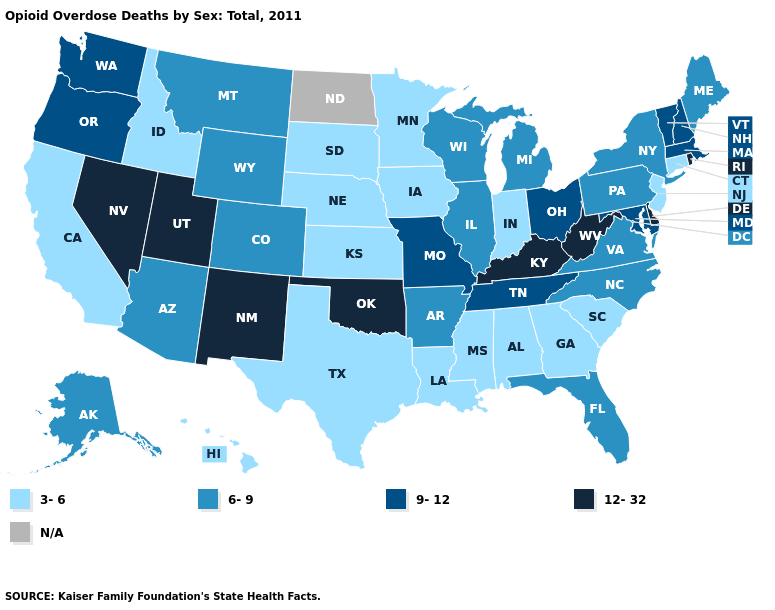What is the highest value in the USA?
Answer briefly. 12-32. What is the value of Texas?
Keep it brief. 3-6. Which states have the highest value in the USA?
Keep it brief. Delaware, Kentucky, Nevada, New Mexico, Oklahoma, Rhode Island, Utah, West Virginia. Which states hav the highest value in the Northeast?
Be succinct. Rhode Island. Name the states that have a value in the range 6-9?
Short answer required. Alaska, Arizona, Arkansas, Colorado, Florida, Illinois, Maine, Michigan, Montana, New York, North Carolina, Pennsylvania, Virginia, Wisconsin, Wyoming. Does Colorado have the lowest value in the USA?
Answer briefly. No. What is the value of North Carolina?
Answer briefly. 6-9. Name the states that have a value in the range 9-12?
Quick response, please. Maryland, Massachusetts, Missouri, New Hampshire, Ohio, Oregon, Tennessee, Vermont, Washington. Name the states that have a value in the range 6-9?
Be succinct. Alaska, Arizona, Arkansas, Colorado, Florida, Illinois, Maine, Michigan, Montana, New York, North Carolina, Pennsylvania, Virginia, Wisconsin, Wyoming. Name the states that have a value in the range 9-12?
Give a very brief answer. Maryland, Massachusetts, Missouri, New Hampshire, Ohio, Oregon, Tennessee, Vermont, Washington. Name the states that have a value in the range 12-32?
Keep it brief. Delaware, Kentucky, Nevada, New Mexico, Oklahoma, Rhode Island, Utah, West Virginia. Does Kentucky have the highest value in the USA?
Give a very brief answer. Yes. Does New Jersey have the lowest value in the Northeast?
Be succinct. Yes. Name the states that have a value in the range 3-6?
Concise answer only. Alabama, California, Connecticut, Georgia, Hawaii, Idaho, Indiana, Iowa, Kansas, Louisiana, Minnesota, Mississippi, Nebraska, New Jersey, South Carolina, South Dakota, Texas. 